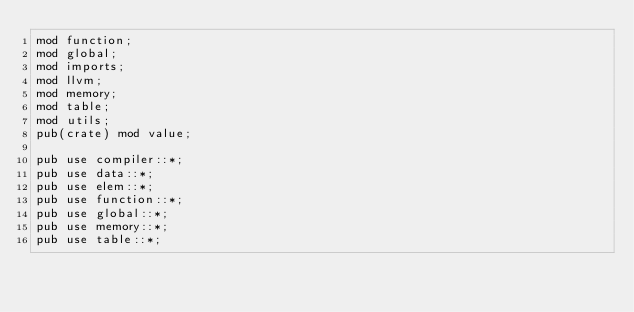<code> <loc_0><loc_0><loc_500><loc_500><_Rust_>mod function;
mod global;
mod imports;
mod llvm;
mod memory;
mod table;
mod utils;
pub(crate) mod value;

pub use compiler::*;
pub use data::*;
pub use elem::*;
pub use function::*;
pub use global::*;
pub use memory::*;
pub use table::*;
</code> 